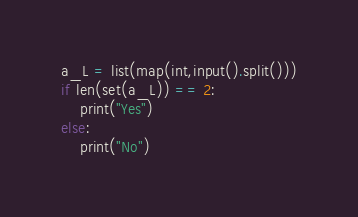<code> <loc_0><loc_0><loc_500><loc_500><_Python_>a_L = list(map(int,input().split()))
if len(set(a_L)) == 2:
    print("Yes")
else:
    print("No")</code> 